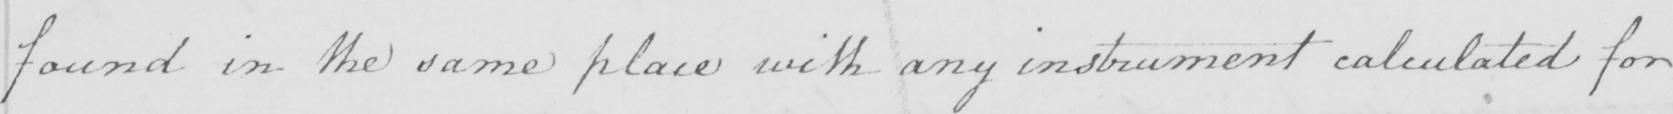Transcribe the text shown in this historical manuscript line. found in the same place with any instrument calculated for 